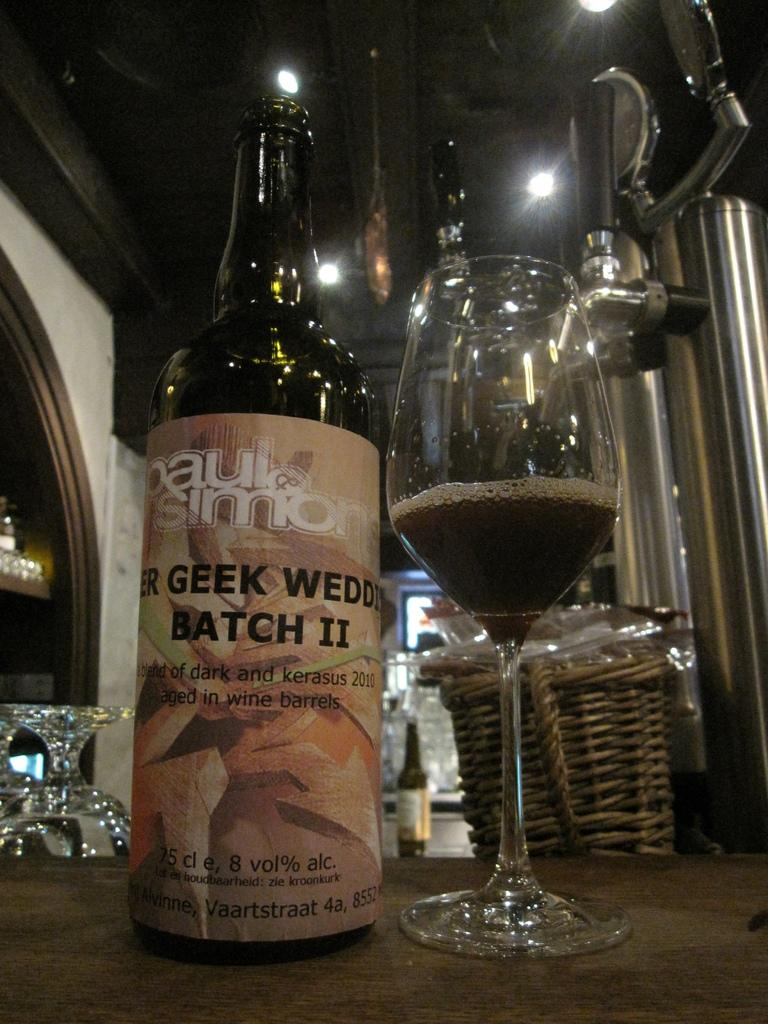What piece of furniture is present in the image? There is a table in the image. What is placed on the table? There is a glass and a bottle on the table. Can you describe any other objects in the image? There are other unspecified objects behind the table. What can be seen on the roof in the image? There are lights on the roof. What invention is being demonstrated by the moon in the image? There is no moon present in the image, and therefore no invention can be demonstrated by it. 